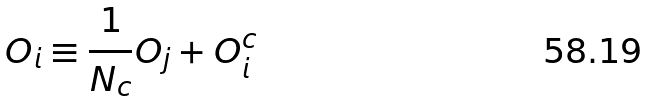<formula> <loc_0><loc_0><loc_500><loc_500>O _ { i } \equiv \frac { 1 } { N _ { c } } O _ { j } + O _ { i } ^ { c }</formula> 